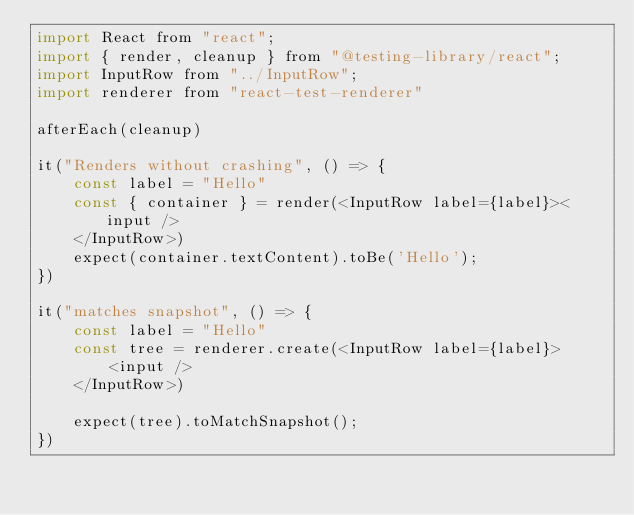Convert code to text. <code><loc_0><loc_0><loc_500><loc_500><_JavaScript_>import React from "react";
import { render, cleanup } from "@testing-library/react";
import InputRow from "../InputRow";
import renderer from "react-test-renderer"

afterEach(cleanup)

it("Renders without crashing", () => {
    const label = "Hello"
    const { container } = render(<InputRow label={label}><input />
    </InputRow>)
    expect(container.textContent).toBe('Hello');
})

it("matches snapshot", () => {
    const label = "Hello"
    const tree = renderer.create(<InputRow label={label}>
        <input />
    </InputRow>)

    expect(tree).toMatchSnapshot();
})</code> 